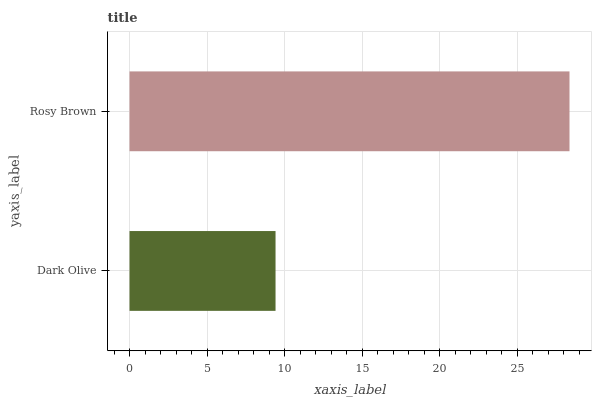Is Dark Olive the minimum?
Answer yes or no. Yes. Is Rosy Brown the maximum?
Answer yes or no. Yes. Is Rosy Brown the minimum?
Answer yes or no. No. Is Rosy Brown greater than Dark Olive?
Answer yes or no. Yes. Is Dark Olive less than Rosy Brown?
Answer yes or no. Yes. Is Dark Olive greater than Rosy Brown?
Answer yes or no. No. Is Rosy Brown less than Dark Olive?
Answer yes or no. No. Is Rosy Brown the high median?
Answer yes or no. Yes. Is Dark Olive the low median?
Answer yes or no. Yes. Is Dark Olive the high median?
Answer yes or no. No. Is Rosy Brown the low median?
Answer yes or no. No. 